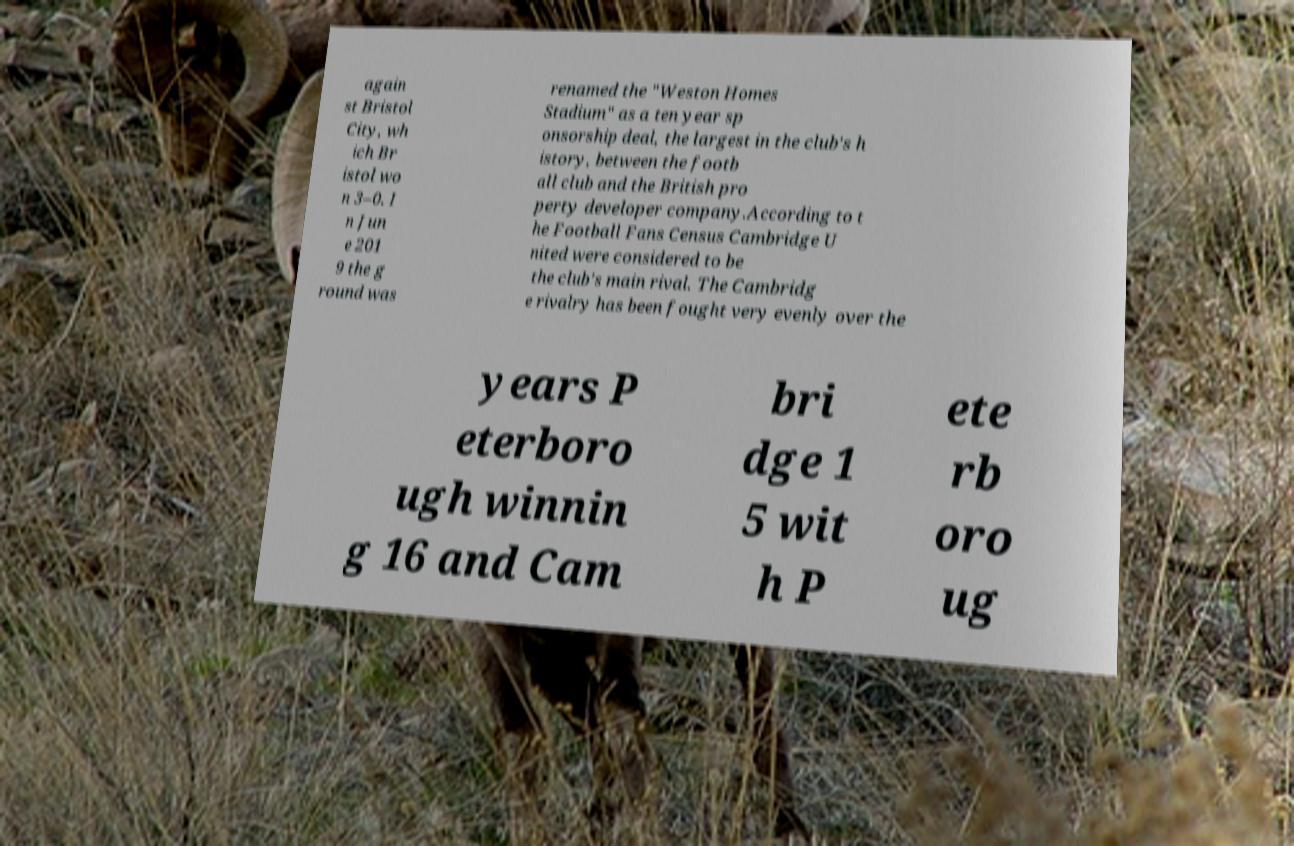Can you accurately transcribe the text from the provided image for me? again st Bristol City, wh ich Br istol wo n 3–0. I n Jun e 201 9 the g round was renamed the "Weston Homes Stadium" as a ten year sp onsorship deal, the largest in the club's h istory, between the footb all club and the British pro perty developer company.According to t he Football Fans Census Cambridge U nited were considered to be the club's main rival. The Cambridg e rivalry has been fought very evenly over the years P eterboro ugh winnin g 16 and Cam bri dge 1 5 wit h P ete rb oro ug 